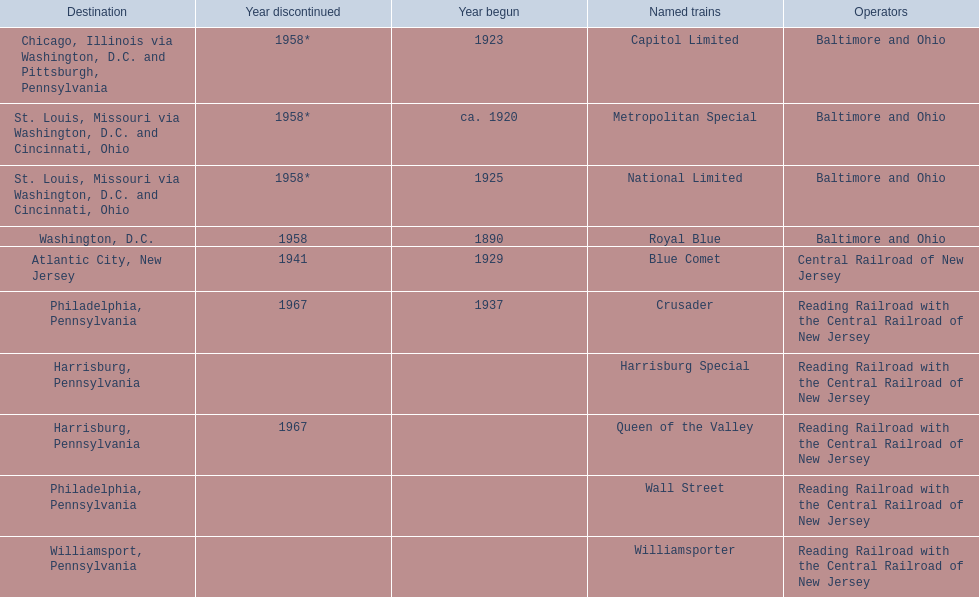What is the total number of year begun? 6. 